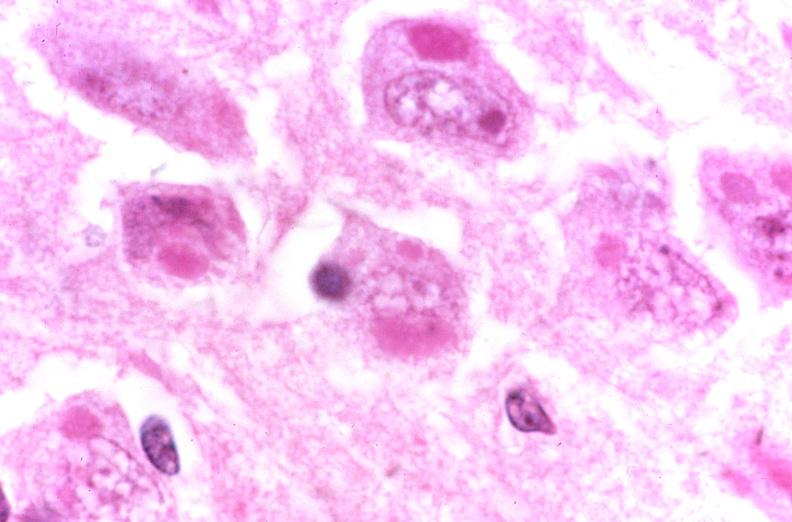s nervous present?
Answer the question using a single word or phrase. Yes 